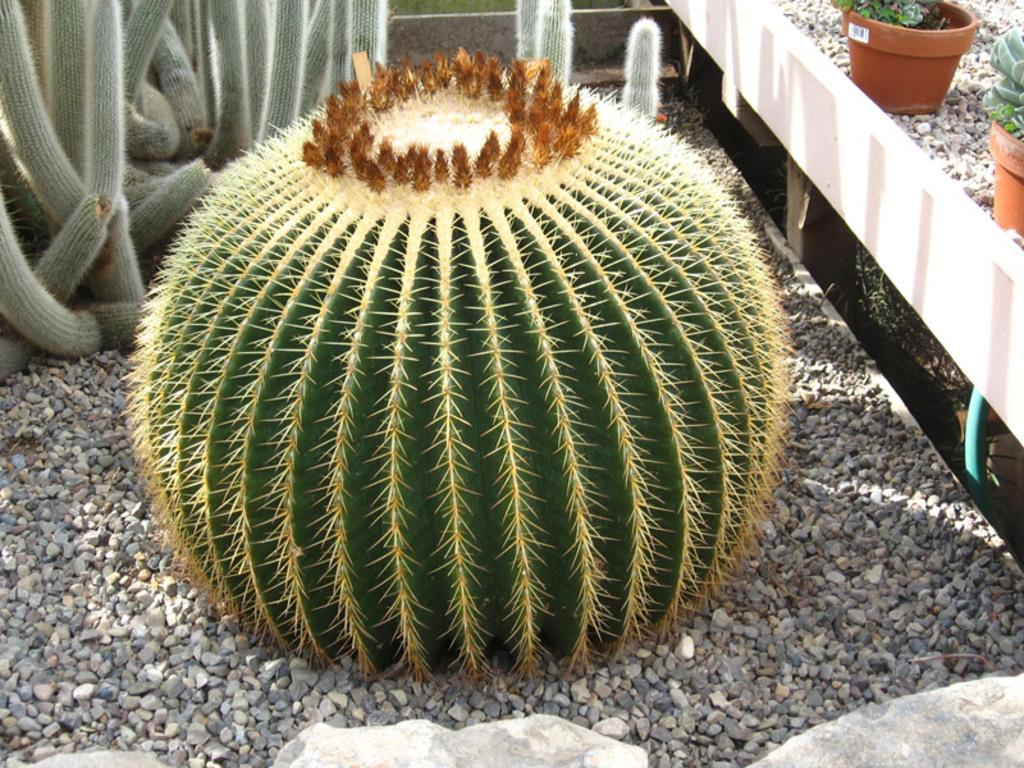What type of vegetation can be seen on the ground in the image? There are plants on the ground in the image. Are there any plants in containers in the image? Yes, there are plants in pots in the image. What other elements can be seen in the image besides plants? There are stones and rocks on the side in the image. How many arms are visible in the image? There are no arms visible in the image; it primarily features plants and stones. 